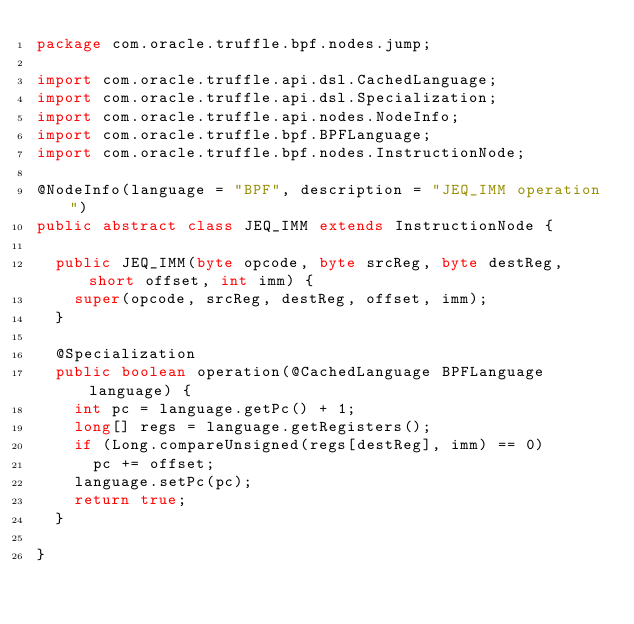Convert code to text. <code><loc_0><loc_0><loc_500><loc_500><_Java_>package com.oracle.truffle.bpf.nodes.jump;

import com.oracle.truffle.api.dsl.CachedLanguage;
import com.oracle.truffle.api.dsl.Specialization;
import com.oracle.truffle.api.nodes.NodeInfo;
import com.oracle.truffle.bpf.BPFLanguage;
import com.oracle.truffle.bpf.nodes.InstructionNode;

@NodeInfo(language = "BPF", description = "JEQ_IMM operation")
public abstract class JEQ_IMM extends InstructionNode {
	
	public JEQ_IMM(byte opcode, byte srcReg, byte destReg, short offset, int imm) {
		super(opcode, srcReg, destReg, offset, imm);
	}

	@Specialization
	public boolean operation(@CachedLanguage BPFLanguage language) {
		int pc = language.getPc() + 1;
		long[] regs = language.getRegisters();
		if (Long.compareUnsigned(regs[destReg], imm) == 0)
			pc += offset;
		language.setPc(pc);
		return true;
	}
	
}
</code> 